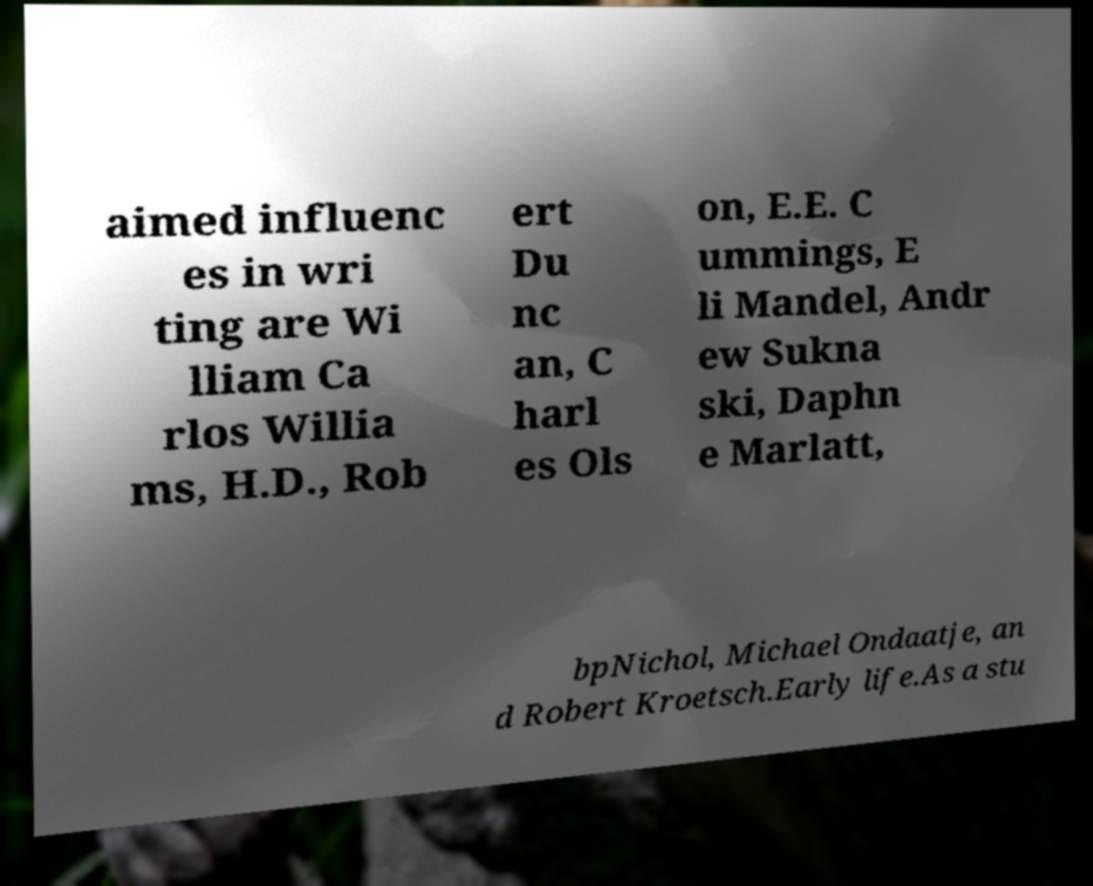Please identify and transcribe the text found in this image. aimed influenc es in wri ting are Wi lliam Ca rlos Willia ms, H.D., Rob ert Du nc an, C harl es Ols on, E.E. C ummings, E li Mandel, Andr ew Sukna ski, Daphn e Marlatt, bpNichol, Michael Ondaatje, an d Robert Kroetsch.Early life.As a stu 